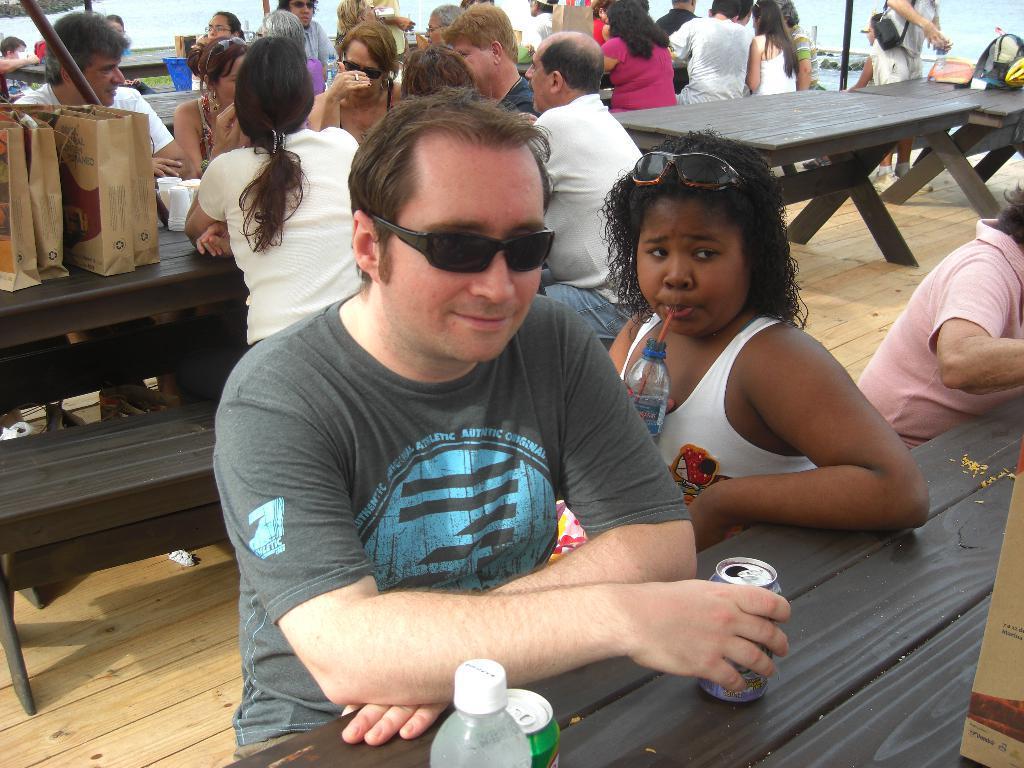Can you describe this image briefly? Most of the persons are sitting on a bench. On this tables there are bags, cups, tins and bottle. Front this man wore goggles. 